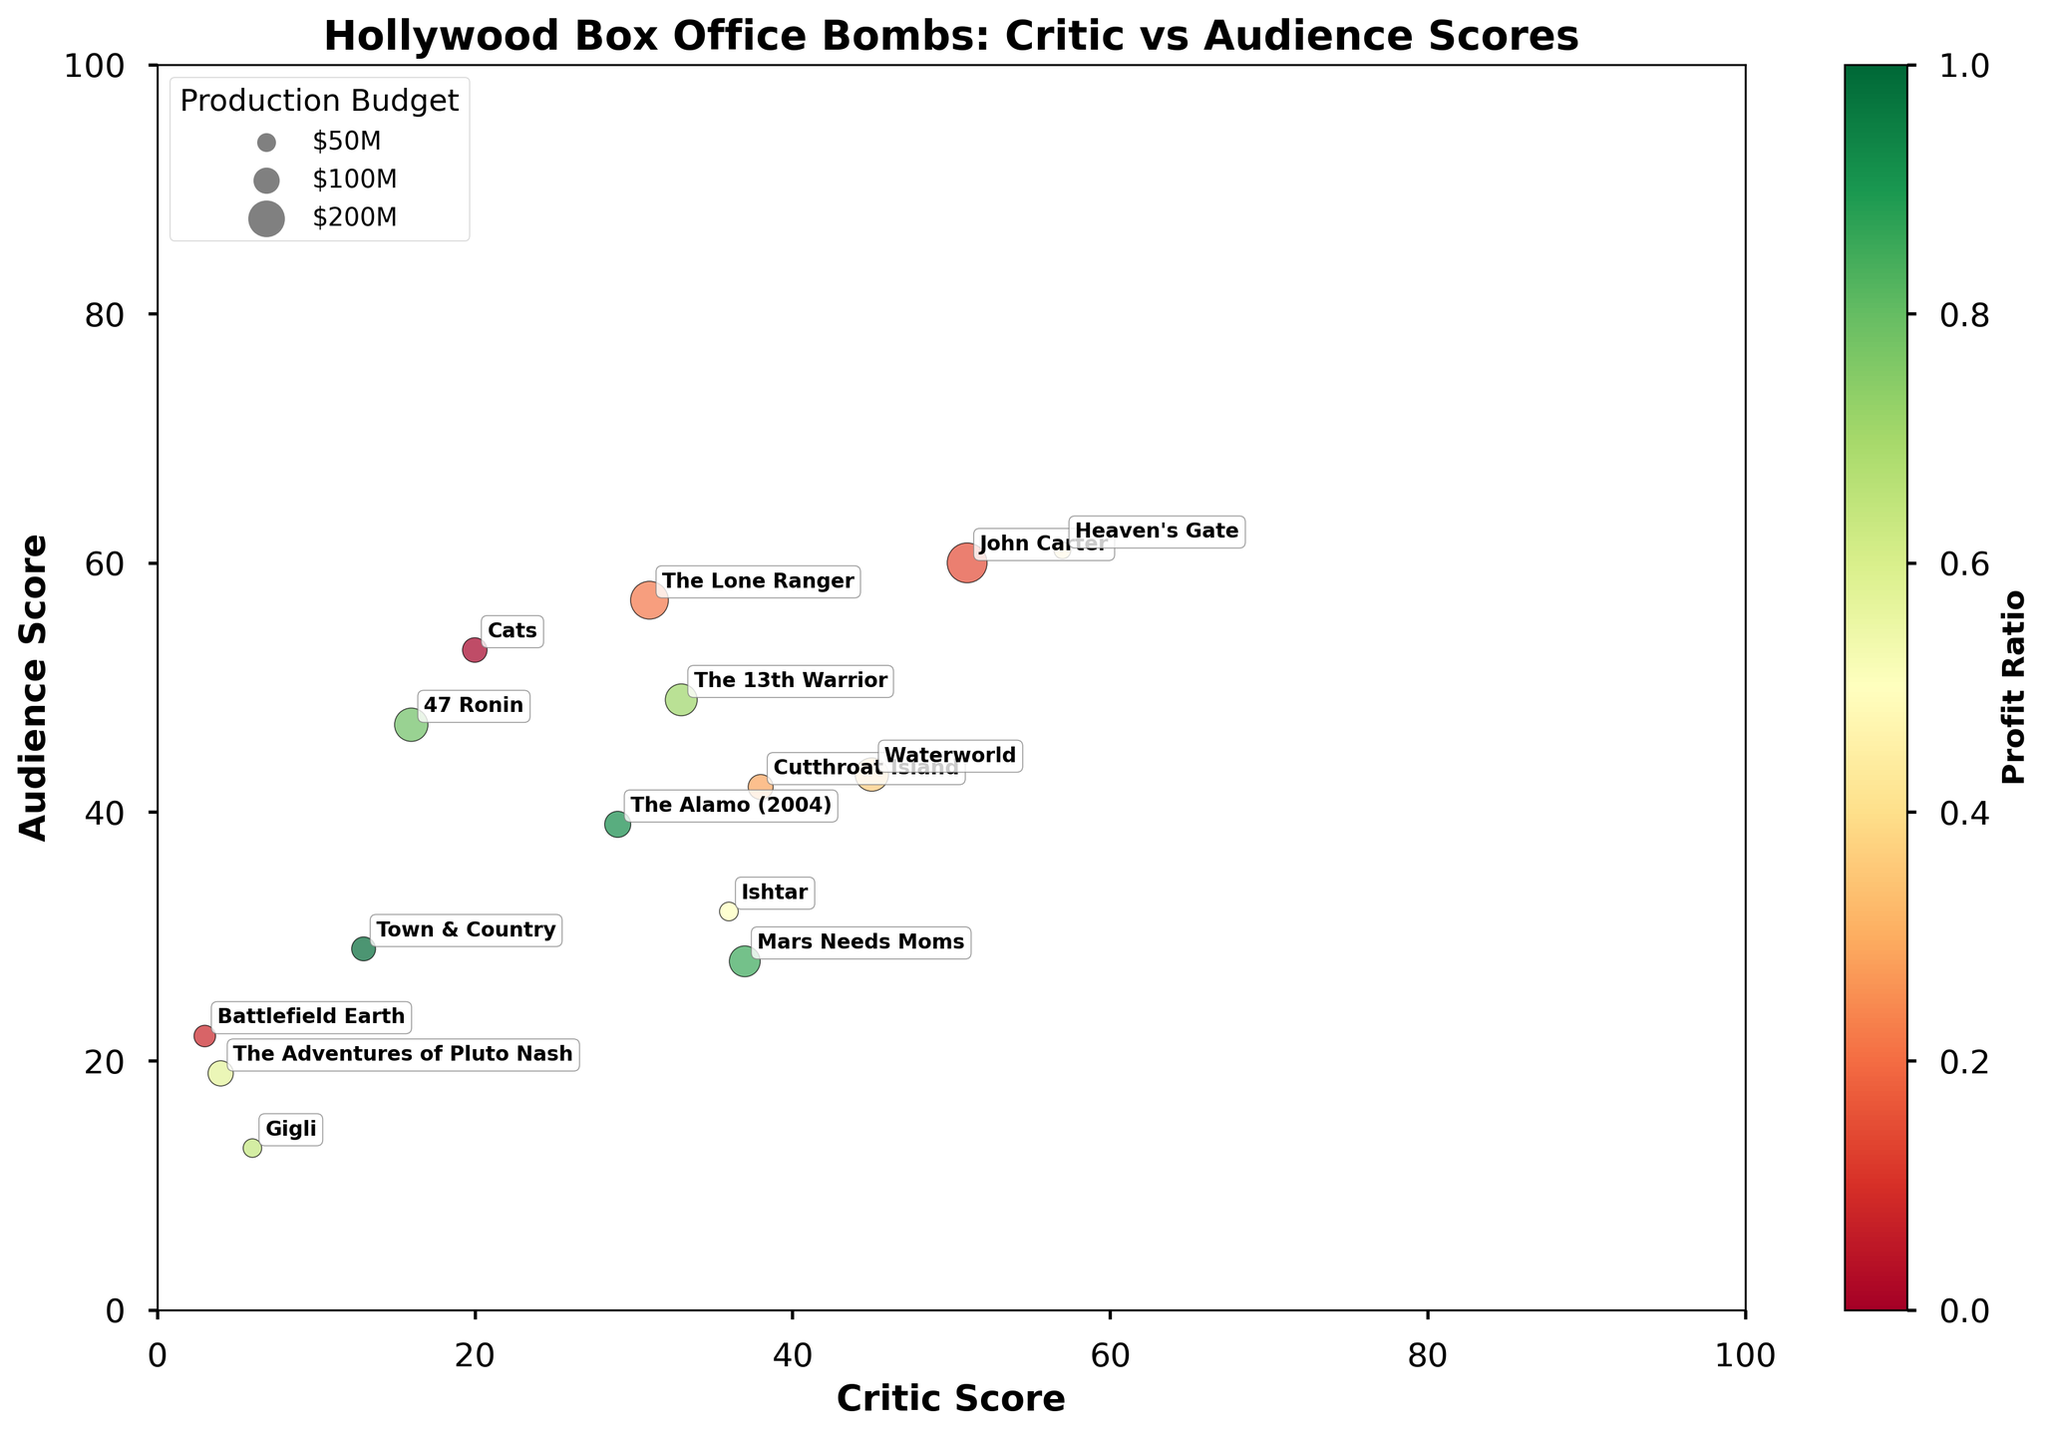What is the title of the plot? The title is located at the top center of the plot in bold text.
Answer: Hollywood Box Office Bombs: Critic vs Audience Scores How many movies have an audience score below 30? By visually inspecting the y-axis, we look for points below the 30 mark. These movies are "Battlefield Earth," "The Adventures of Pluto Nash," "Gigli," "Mars Needs Moms," and "Town & Country."
Answer: 5 Which movie has the highest critic score? By inspecting the x-axis, we identify the furthest point to the right. The movie annotated as such is "Heaven's Gate."
Answer: Heaven's Gate What is the profit ratio color code of the movies? The color scale varies from red to green, with red indicating a negative profit ratio and green indicating a positive profit ratio.
Answer: Red to Green Which two movies have the most similar critic and audience scores? We compare the positions of the points and their annotations to find the two movies closest to each other in both x and y axes. These are "John Carter" and "Heaven's Gate."
Answer: John Carter and Heaven's Gate Which movie had the largest production budget? The size of the bubble represents the production budget. The largest bubble in the plot represents the movie with the largest budget, which is "John Carter."
Answer: John Carter What is the evident trend between critic scores and audience scores for these movies? We observe the overall placement of the points. The trend appears to be inconsistent, with no clear relationship between critic scores and audience scores. Some movies have higher critic scores, while others have higher audience scores. This inconsistency indicates there is no straightforward correlation for the box office bombs depicted.
Answer: Inconsistent trend Identify a movie with a low critic score but relatively high audience score. From visual inspection, look for points on the left side of the x-axis with a higher position on the y-axis. One such movie is "Cats," which has a low critic score but a relatively higher audience score compared to other points in its vicinity.
Answer: Cats Comparing "The Lone Ranger" and "Waterworld," which movie had a better audience reception? By comparing the y-axis values of the points annotated with these movie titles, "Waterworld" is slightly higher on the y-axis than "The Lone Ranger."
Answer: Waterworld 